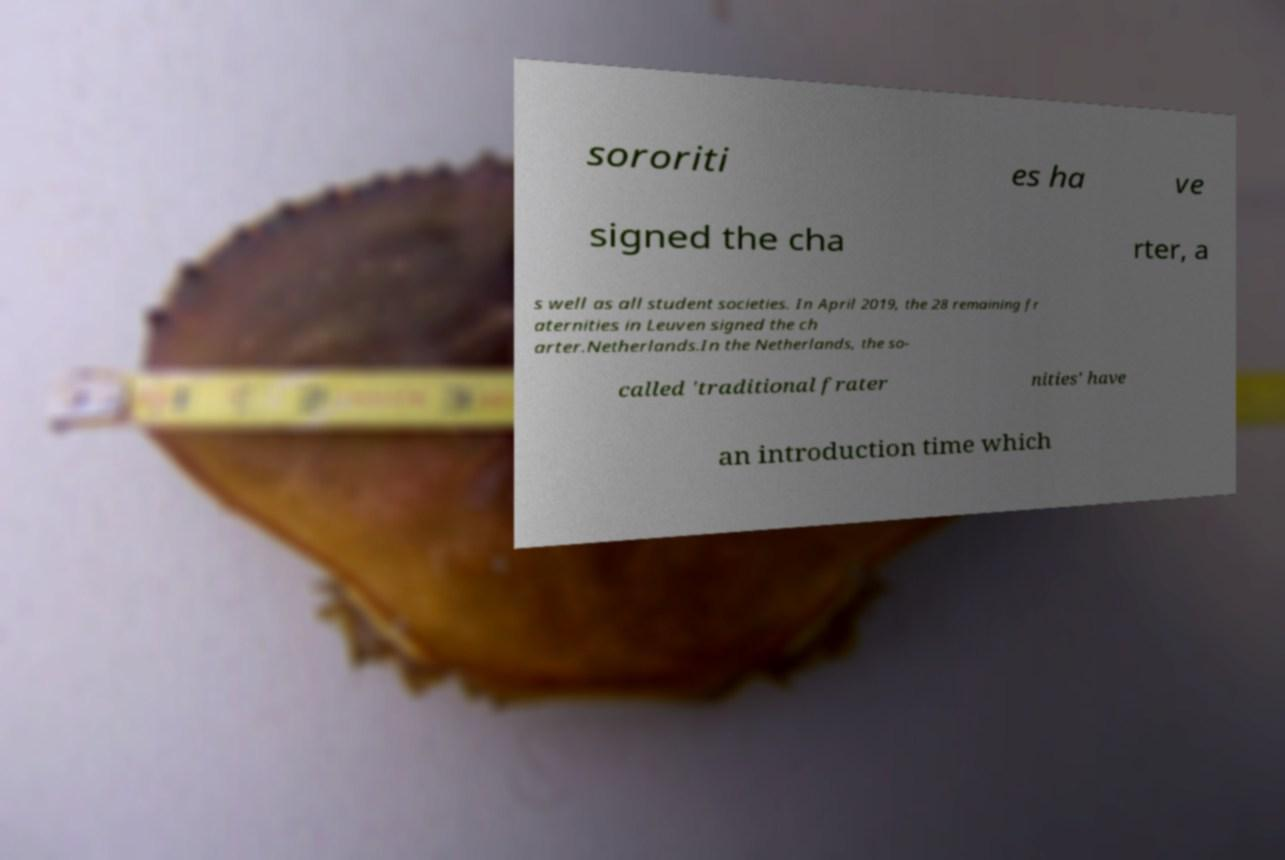Please identify and transcribe the text found in this image. sororiti es ha ve signed the cha rter, a s well as all student societies. In April 2019, the 28 remaining fr aternities in Leuven signed the ch arter.Netherlands.In the Netherlands, the so- called 'traditional frater nities' have an introduction time which 